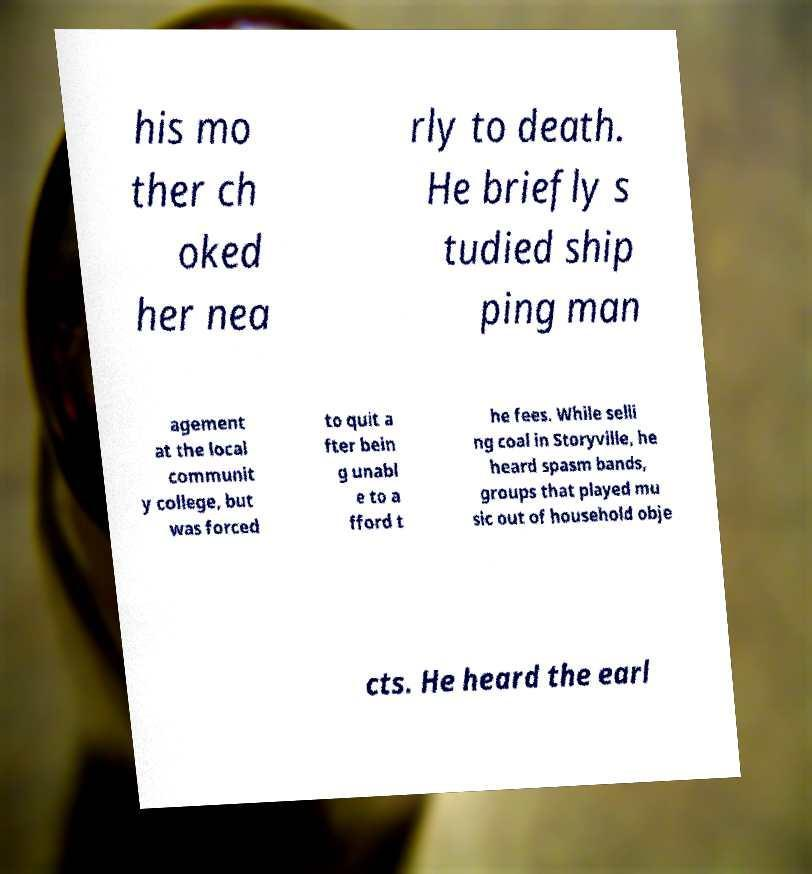I need the written content from this picture converted into text. Can you do that? his mo ther ch oked her nea rly to death. He briefly s tudied ship ping man agement at the local communit y college, but was forced to quit a fter bein g unabl e to a fford t he fees. While selli ng coal in Storyville, he heard spasm bands, groups that played mu sic out of household obje cts. He heard the earl 